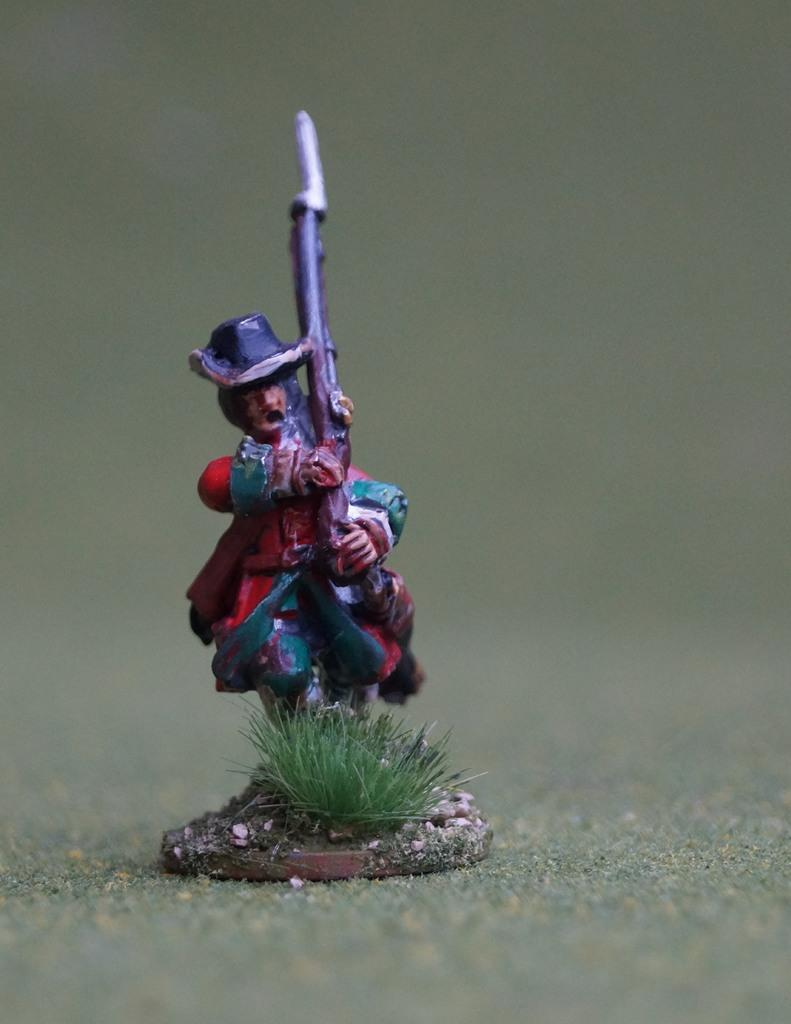What object can be seen in the image? There is a toy in the image. Where is the toy located? The toy is kept on the floor. What type of stocking is the toy wearing in the image? There is no stocking present in the image, as the toy is not a person or an animal that would wear stockings. 